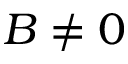<formula> <loc_0><loc_0><loc_500><loc_500>B \neq 0</formula> 